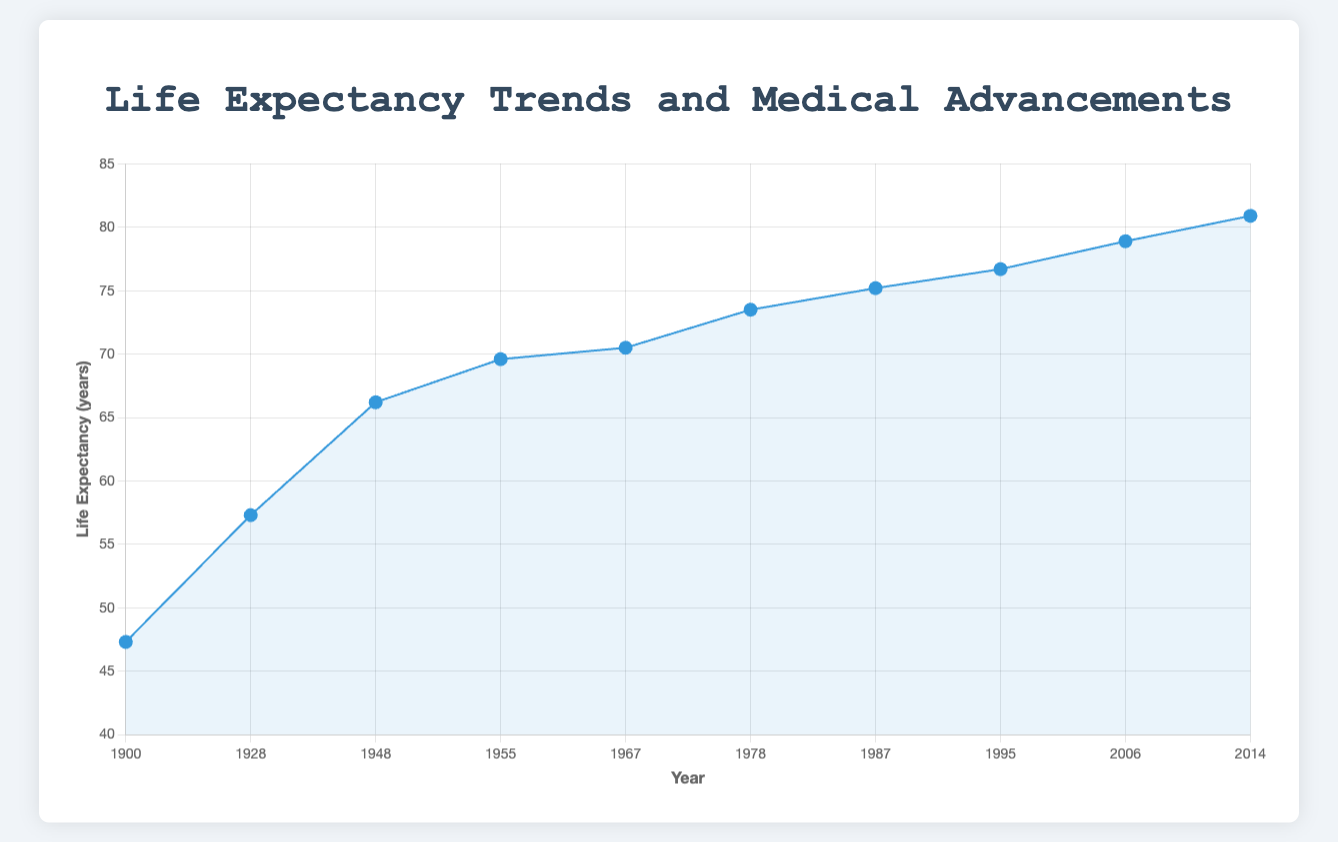What major event occurred in conjunction with an approximate 20-year increase in life expectancy between 1900 and 1928? The life expectancy increases from 47.3 years in 1900 to 57.3 years in 1928. The major events are the introduction of basic sanitation and sewage treatment in 1900 and the discovery of penicillin in 1928.
Answer: Discovery of penicillin What was the life expectancy in 1948, and which major event is associated with it? In 1948, the life expectancy is 66.2 years. The associated major event is the establishment of the National Health Service in the United Kingdom.
Answer: 66.2 years Compare the impact on life expectancy between the introduction of the polio vaccine in 1955 and the antiretroviral therapy for HIV/AIDS in 1987. Which event resulted in a higher life expectancy? The introduction of the polio vaccine in 1955 resulted in a life expectancy of 69.6 years, whereas the introduction of antiretroviral therapy for HIV/AIDS in 1987 resulted in a life expectancy of 75.2 years. Antiretroviral therapy for HIV/AIDS had a higher life expectancy.
Answer: Introduction of antiretroviral therapy for HIV/AIDS What is the average life expectancy growth per decade from 1900 to 1948? To find the average growth per decade, first calculate the total increase in life expectancy from 1900 (47.3 years) to 1948 (66.2 years), which is 66.2 - 47.3 = 18.9 years. There are 4.8 decades in this period. Thus, the average growth per decade is 18.9 / 4.8 ≈ 3.94 years.
Answer: 3.94 years per decade How does the life expectancy in 2006 compare to that in 1987? The life expectancy in 2006 is 78.9 years, whereas in 1987 it was 75.2 years. By comparing these numbers, life expectancy increased by 78.9 - 75.2 = 3.7 years.
Answer: 3.7 years increase What was the major global health policy implemented in 1978, and what is its corresponding life expectancy? In 1978, the major global health policy was the implementation of the Alma-Ata Declaration on primary health care, with a corresponding life expectancy of 73.5 years.
Answer: Alma-Ata Declaration on primary health care, 73.5 years What is the total increase in life expectancy from 1900 to 2014, and what major health focus was emphasized in 2014? The life expectancy increased from 47.3 years in 1900 to 80.9 years in 2014, resulting in a total increase of 80.9 - 47.3 = 33.6 years. In 2014, there was an increased focus on non-communicable diseases and preventive healthcare.
Answer: 33.6 years increase, non-communicable diseases and preventive healthcare Which year had the highest life expectancy, and what was the primary health initiative of that year? The year with the highest life expectancy is 2014, with a life expectancy of 80.9 years. The primary health initiative of that year was an increased focus on non-communicable diseases and preventive healthcare.
Answer: 2014, non-communicable diseases and preventive healthcare Evaluate the increase in life expectancy from the discovery of penicillin (1928) to the introduction of the HPV vaccine (2006). How much did life expectancy increase, and which major events fall within this period? The life expectancy increased from 57.3 years in 1928 to 78.9 years in 2006, resulting in an increase of 78.9 - 57.3 = 21.6 years. Major events in this period include the establishment of the NHS (1948), the introduction of the polio vaccine (1955), the use of the measles vaccine (1967), the Alma-Ata Declaration (1978), antiretroviral therapy for HIV/AIDS (1987), and the varicella vaccine (1995).
Answer: 21.6 years, multiple events including NHS, polio vaccine, measles vaccine, Alma-Ata Declaration, antiretroviral therapy, varicella vaccine 